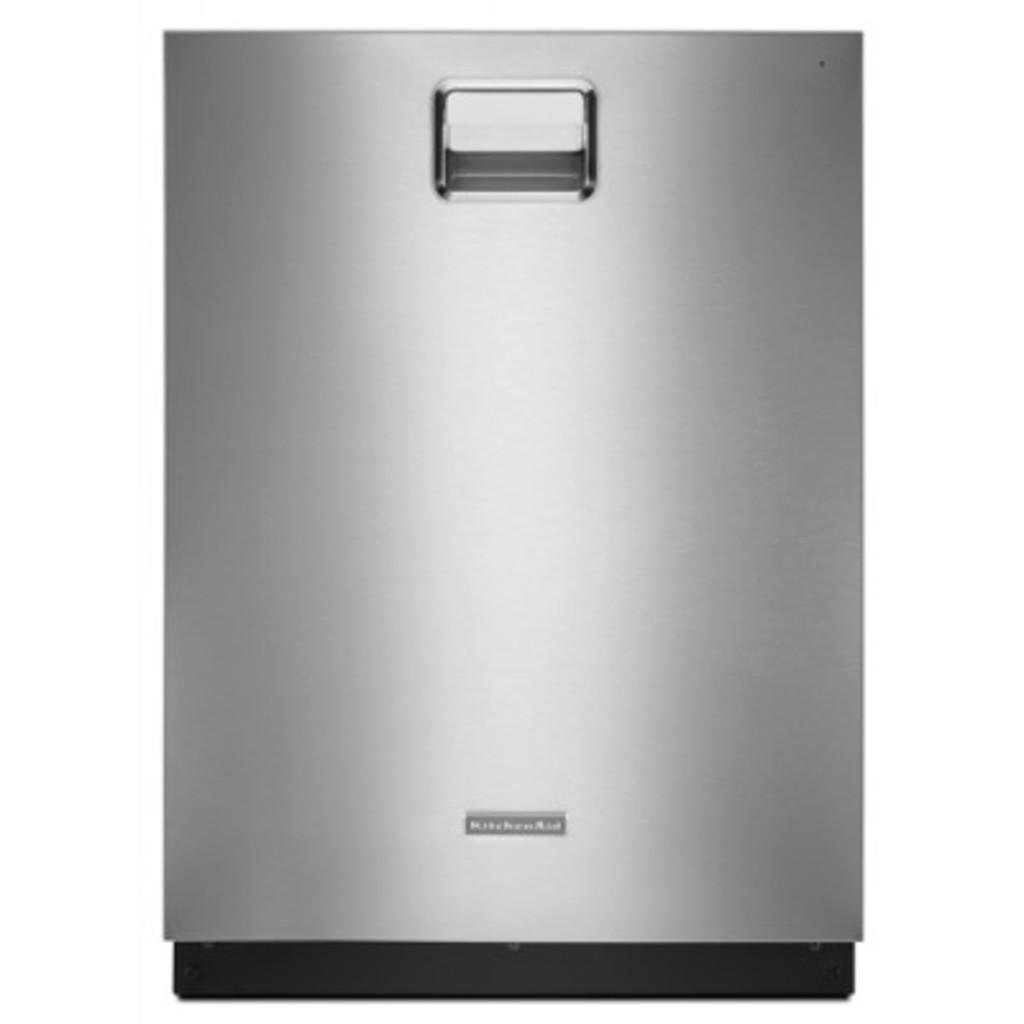How would you summarize this image in a sentence or two? In this image I can see an object which is in ash color. 